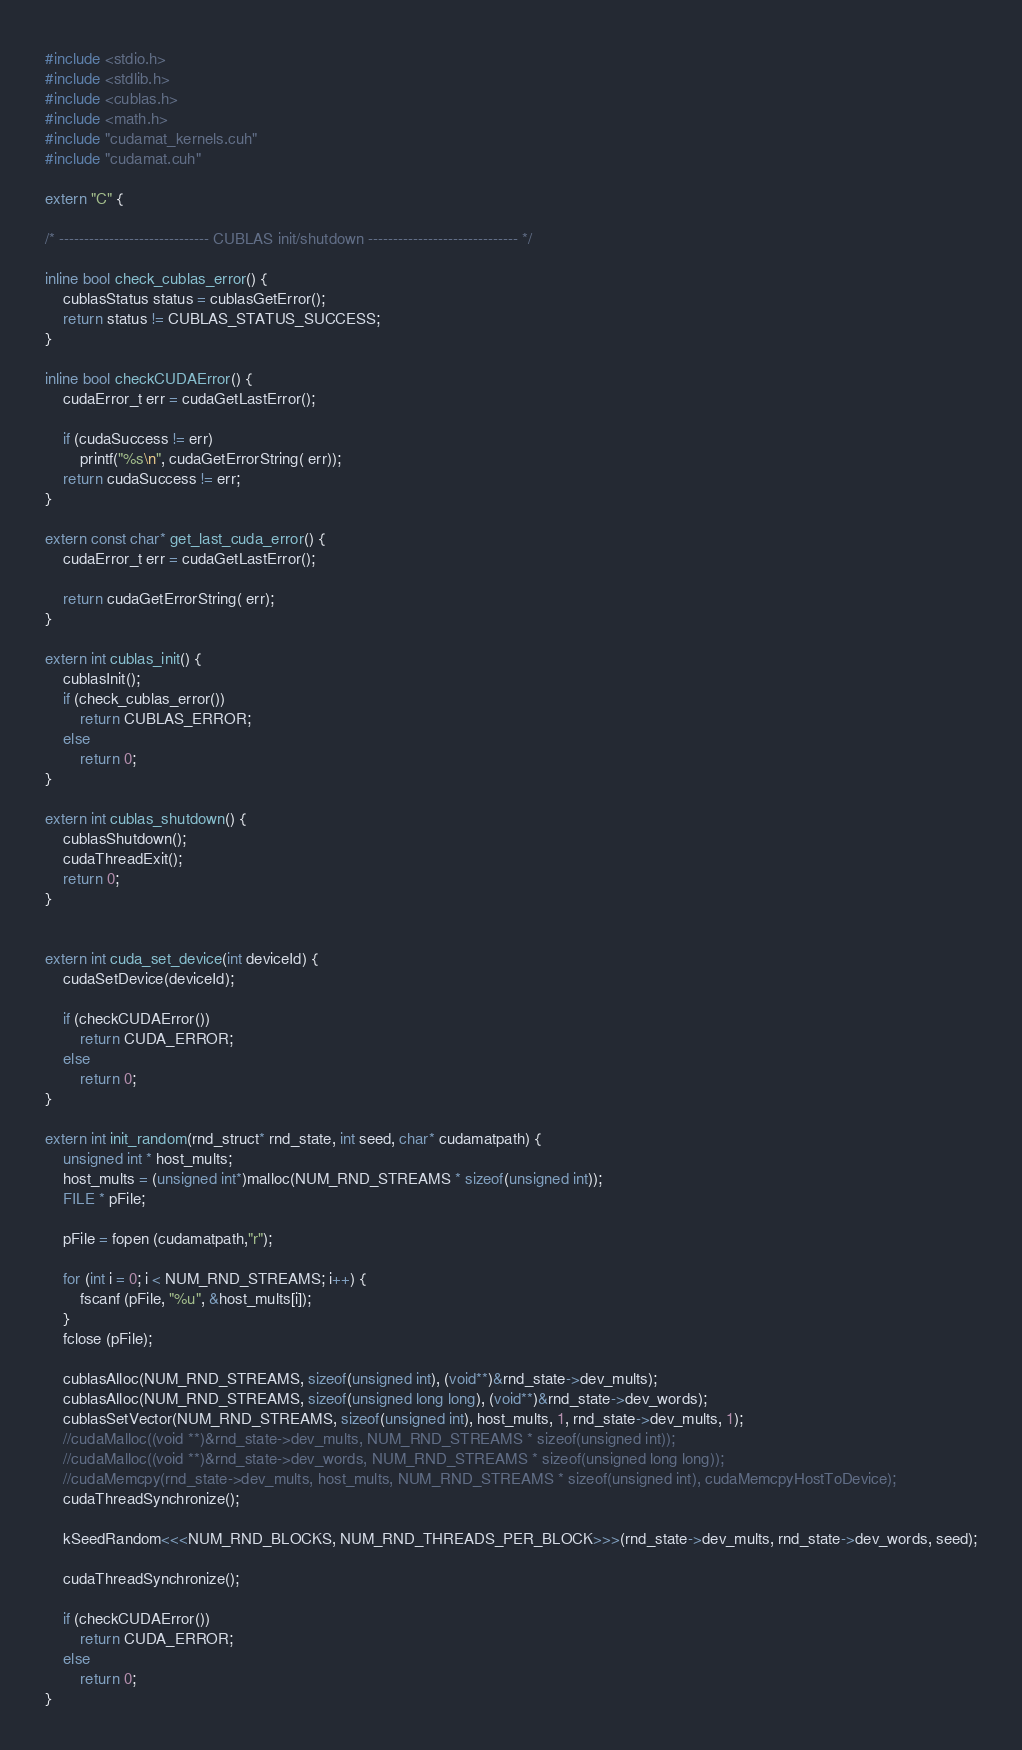Convert code to text. <code><loc_0><loc_0><loc_500><loc_500><_Cuda_>#include <stdio.h>
#include <stdlib.h>
#include <cublas.h>
#include <math.h>
#include "cudamat_kernels.cuh"
#include "cudamat.cuh"

extern "C" {

/* ------------------------------ CUBLAS init/shutdown ------------------------------ */

inline bool check_cublas_error() {
    cublasStatus status = cublasGetError();
    return status != CUBLAS_STATUS_SUCCESS;
}

inline bool checkCUDAError() {
    cudaError_t err = cudaGetLastError();

    if (cudaSuccess != err)
        printf("%s\n", cudaGetErrorString( err));
    return cudaSuccess != err;
}

extern const char* get_last_cuda_error() {
    cudaError_t err = cudaGetLastError();

    return cudaGetErrorString( err);
}

extern int cublas_init() {
    cublasInit();
    if (check_cublas_error())
        return CUBLAS_ERROR;
    else
        return 0;
}

extern int cublas_shutdown() {
    cublasShutdown();
    cudaThreadExit();
    return 0;
}


extern int cuda_set_device(int deviceId) {
    cudaSetDevice(deviceId);
    
    if (checkCUDAError())
        return CUDA_ERROR;
    else
        return 0;
}

extern int init_random(rnd_struct* rnd_state, int seed, char* cudamatpath) {
    unsigned int * host_mults;
    host_mults = (unsigned int*)malloc(NUM_RND_STREAMS * sizeof(unsigned int));
    FILE * pFile;

    pFile = fopen (cudamatpath,"r");

    for (int i = 0; i < NUM_RND_STREAMS; i++) {
        fscanf (pFile, "%u", &host_mults[i]);
    }
    fclose (pFile);

    cublasAlloc(NUM_RND_STREAMS, sizeof(unsigned int), (void**)&rnd_state->dev_mults);
    cublasAlloc(NUM_RND_STREAMS, sizeof(unsigned long long), (void**)&rnd_state->dev_words);
    cublasSetVector(NUM_RND_STREAMS, sizeof(unsigned int), host_mults, 1, rnd_state->dev_mults, 1);
    //cudaMalloc((void **)&rnd_state->dev_mults, NUM_RND_STREAMS * sizeof(unsigned int));
    //cudaMalloc((void **)&rnd_state->dev_words, NUM_RND_STREAMS * sizeof(unsigned long long));
    //cudaMemcpy(rnd_state->dev_mults, host_mults, NUM_RND_STREAMS * sizeof(unsigned int), cudaMemcpyHostToDevice);
    cudaThreadSynchronize();

    kSeedRandom<<<NUM_RND_BLOCKS, NUM_RND_THREADS_PER_BLOCK>>>(rnd_state->dev_mults, rnd_state->dev_words, seed);

    cudaThreadSynchronize();

    if (checkCUDAError())
        return CUDA_ERROR;
    else
        return 0;
}
</code> 